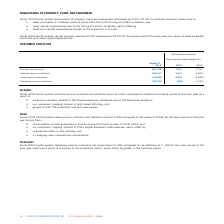According to Cogeco's financial document, What were the total number of internet service customers net additions in fourth quarter 2019?  According to the financial document, 2,441. The relevant text states: "Internet service customers 446,137 2,441 4,693..." Also, What were the total number of video service customers net additions in fourth quarter 2019?  According to the financial document, 5,294. The relevant text states: "Video service customers 312,555 5,294 (3,046)..." Also, What were the total number of telephony service customers net losses in fourth quarter 2019?  According to the financial document, 304. The relevant text states: "Telephony service customers 142,754 (304) 1,150 Telephony service customers 142,754 (304) 1,150..." Also, can you calculate: What was the increase / (decrease) in Net additions (losses) for the Primary service units from 31 Aug 2018 to 31 Aug 2019? Based on the calculation: 7,431 - 2,797, the result is 4634. This is based on the information: "Primary service units 901,446 7,431 2,797 Primary service units 901,446 7,431 2,797..." The key data points involved are: 2,797, 7,431. Also, can you calculate: What was the average Net additions (losses) for internet service customers? To answer this question, I need to perform calculations using the financial data. The calculation is: (2,441 + 4,693) / 2, which equals 3567. This is based on the information: "Internet service customers 446,137 2,441 4,693 Internet service customers 446,137 2,441 4,693..." The key data points involved are: 2,441, 4,693. Also, can you calculate: What was the average Net additions (losses) for video service customers? To answer this question, I need to perform calculations using the financial data. The calculation is: (5,294 + (- 3,046)) / 2, which equals 1124. This is based on the information: "Video service customers 312,555 5,294 (3,046) Video service customers 312,555 5,294 (3,046) Video service customers 312,555 5,294 (3,046)..." The key data points involved are: 3,046, 5,294. 